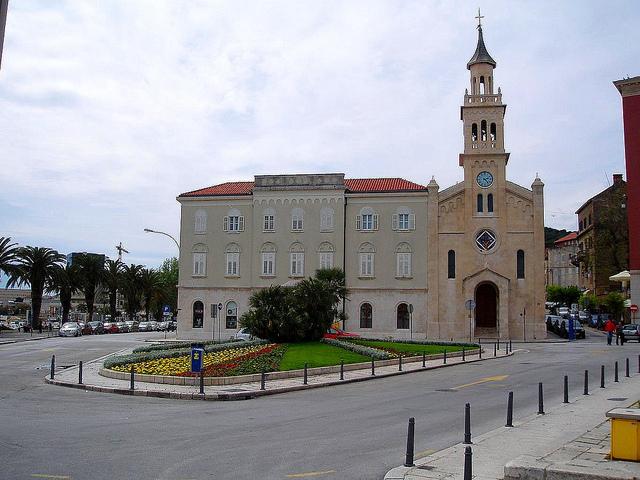Is the area in front of the building landscaped?
Give a very brief answer. Yes. Is this a tower clock?
Short answer required. Yes. What is in the blue box near the flowers?
Short answer required. Phone. 